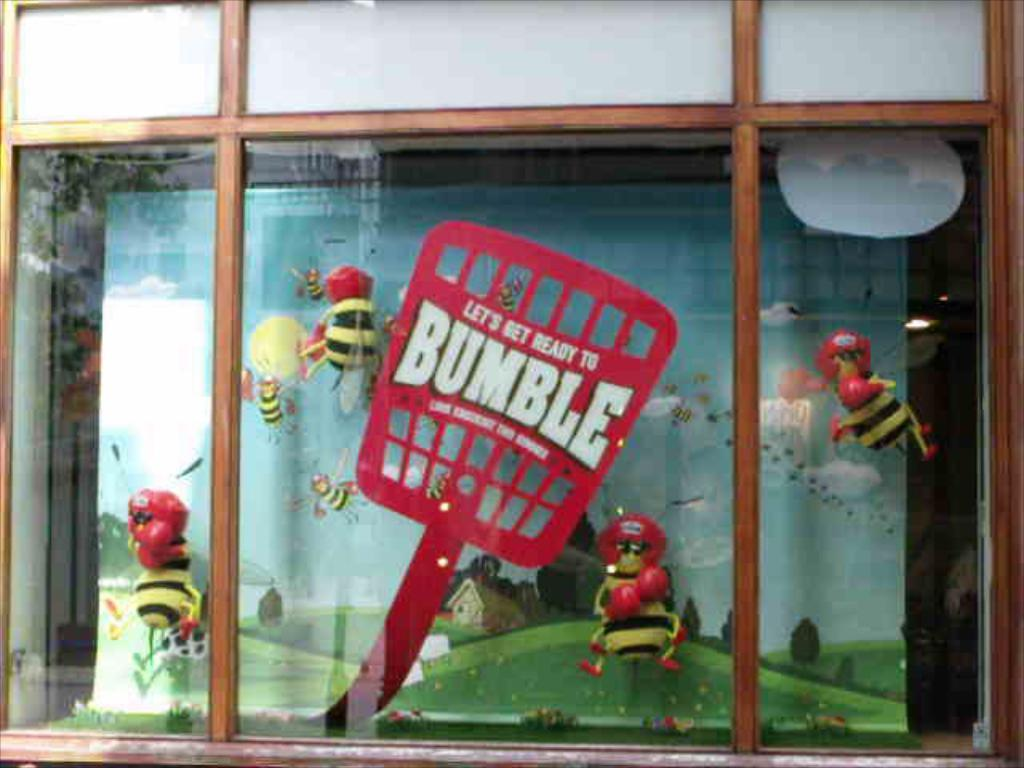What type of furniture is present in the image? There is a glass cupboard in the image. What can be found inside the cupboard? There are toys inside the cupboard. What colors are the toys in the cupboard? The toys are in red and yellow colors. What type of yarn is being used to create the toys in the image? There is no yarn present in the image; the toys are already made and inside the cupboard. What sound do the toys make when played with in the image? The image does not provide any information about the toys making sounds when played with. 